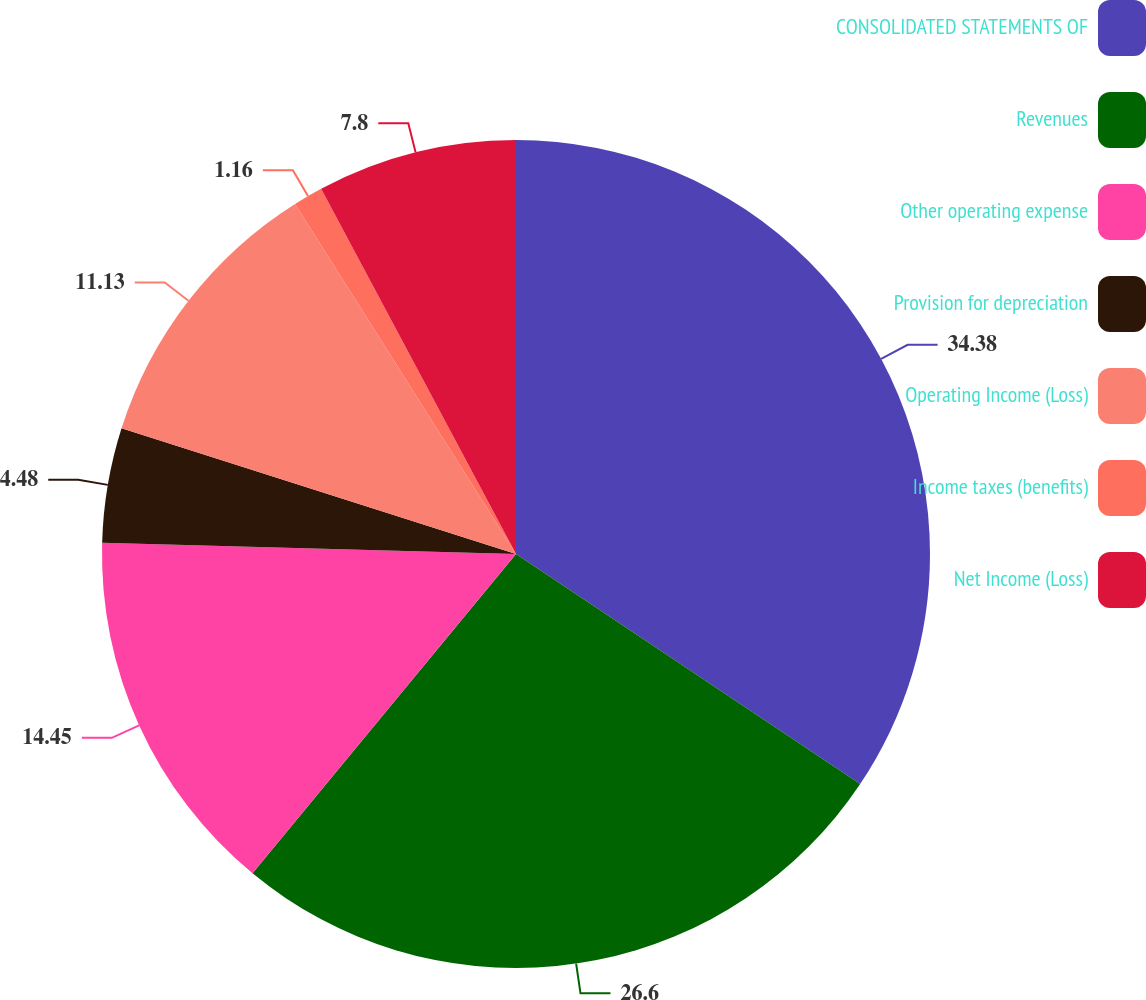Convert chart. <chart><loc_0><loc_0><loc_500><loc_500><pie_chart><fcel>CONSOLIDATED STATEMENTS OF<fcel>Revenues<fcel>Other operating expense<fcel>Provision for depreciation<fcel>Operating Income (Loss)<fcel>Income taxes (benefits)<fcel>Net Income (Loss)<nl><fcel>34.38%<fcel>26.6%<fcel>14.45%<fcel>4.48%<fcel>11.13%<fcel>1.16%<fcel>7.8%<nl></chart> 